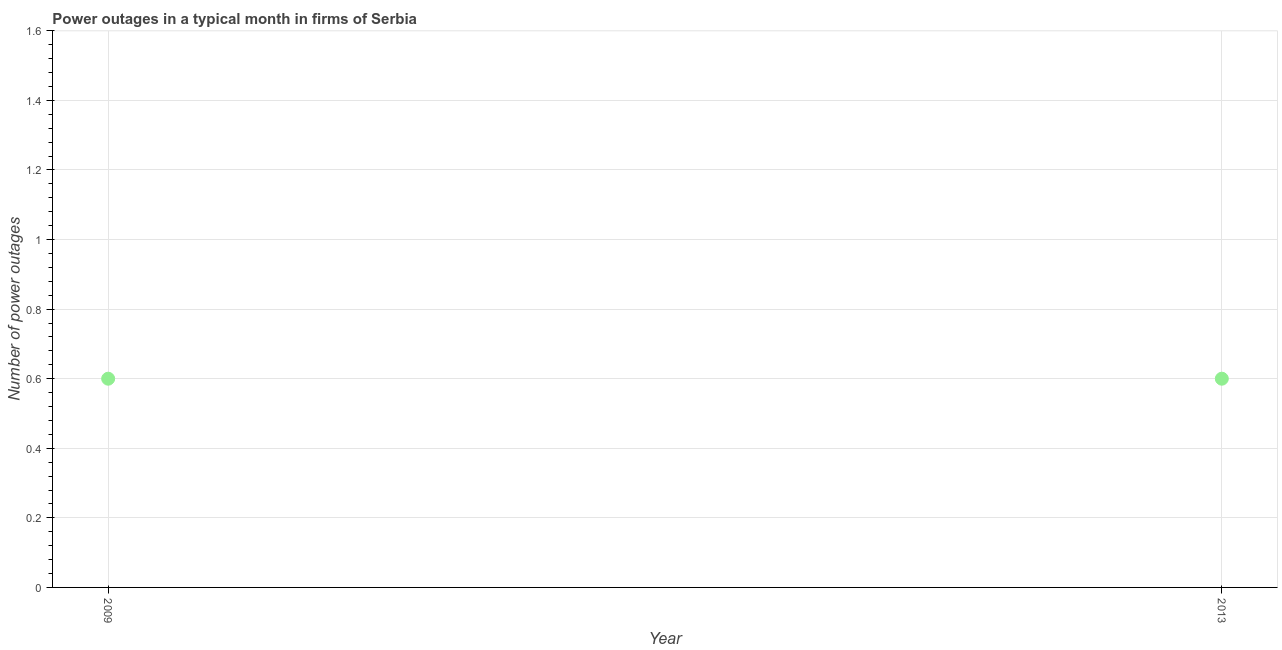What is the number of power outages in 2009?
Your response must be concise. 0.6. Across all years, what is the minimum number of power outages?
Your response must be concise. 0.6. In which year was the number of power outages maximum?
Your answer should be very brief. 2009. In which year was the number of power outages minimum?
Offer a terse response. 2009. What is the average number of power outages per year?
Your response must be concise. 0.6. What is the median number of power outages?
Provide a succinct answer. 0.6. In how many years, is the number of power outages greater than 0.24000000000000002 ?
Offer a terse response. 2. Is the number of power outages in 2009 less than that in 2013?
Your answer should be very brief. No. Does the number of power outages monotonically increase over the years?
Make the answer very short. No. How many dotlines are there?
Your answer should be very brief. 1. What is the difference between two consecutive major ticks on the Y-axis?
Your response must be concise. 0.2. Does the graph contain grids?
Give a very brief answer. Yes. What is the title of the graph?
Offer a very short reply. Power outages in a typical month in firms of Serbia. What is the label or title of the Y-axis?
Your response must be concise. Number of power outages. What is the Number of power outages in 2009?
Offer a very short reply. 0.6. 